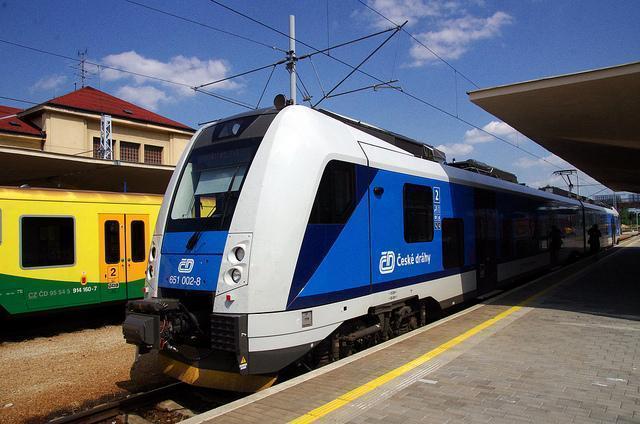Where is the train from?
Answer the question by selecting the correct answer among the 4 following choices and explain your choice with a short sentence. The answer should be formatted with the following format: `Answer: choice
Rationale: rationale.`
Options: Czech republic, america, china, japan. Answer: czech republic.
Rationale: That's where ceske drahy operates. 